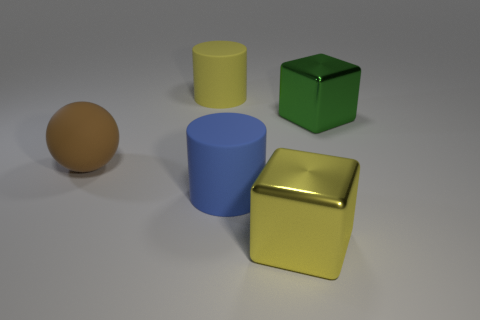What shape is the yellow rubber object?
Offer a very short reply. Cylinder. There is a big yellow thing that is behind the large cube that is behind the blue cylinder; what is it made of?
Make the answer very short. Rubber. What number of other objects are there of the same material as the big yellow block?
Provide a short and direct response. 1. What material is the green cube that is the same size as the brown ball?
Keep it short and to the point. Metal. Is the number of green cubes in front of the blue cylinder greater than the number of large brown balls on the right side of the brown rubber ball?
Offer a very short reply. No. Is there a small gray metal thing that has the same shape as the big green thing?
Keep it short and to the point. No. There is a yellow metal object that is the same size as the blue rubber thing; what shape is it?
Your response must be concise. Cube. What shape is the large yellow object that is in front of the green thing?
Ensure brevity in your answer.  Cube. Are there fewer big brown matte spheres in front of the large brown ball than cubes that are right of the blue rubber thing?
Offer a terse response. Yes. There is a brown object; is its size the same as the yellow object that is in front of the green metallic thing?
Your answer should be compact. Yes. 